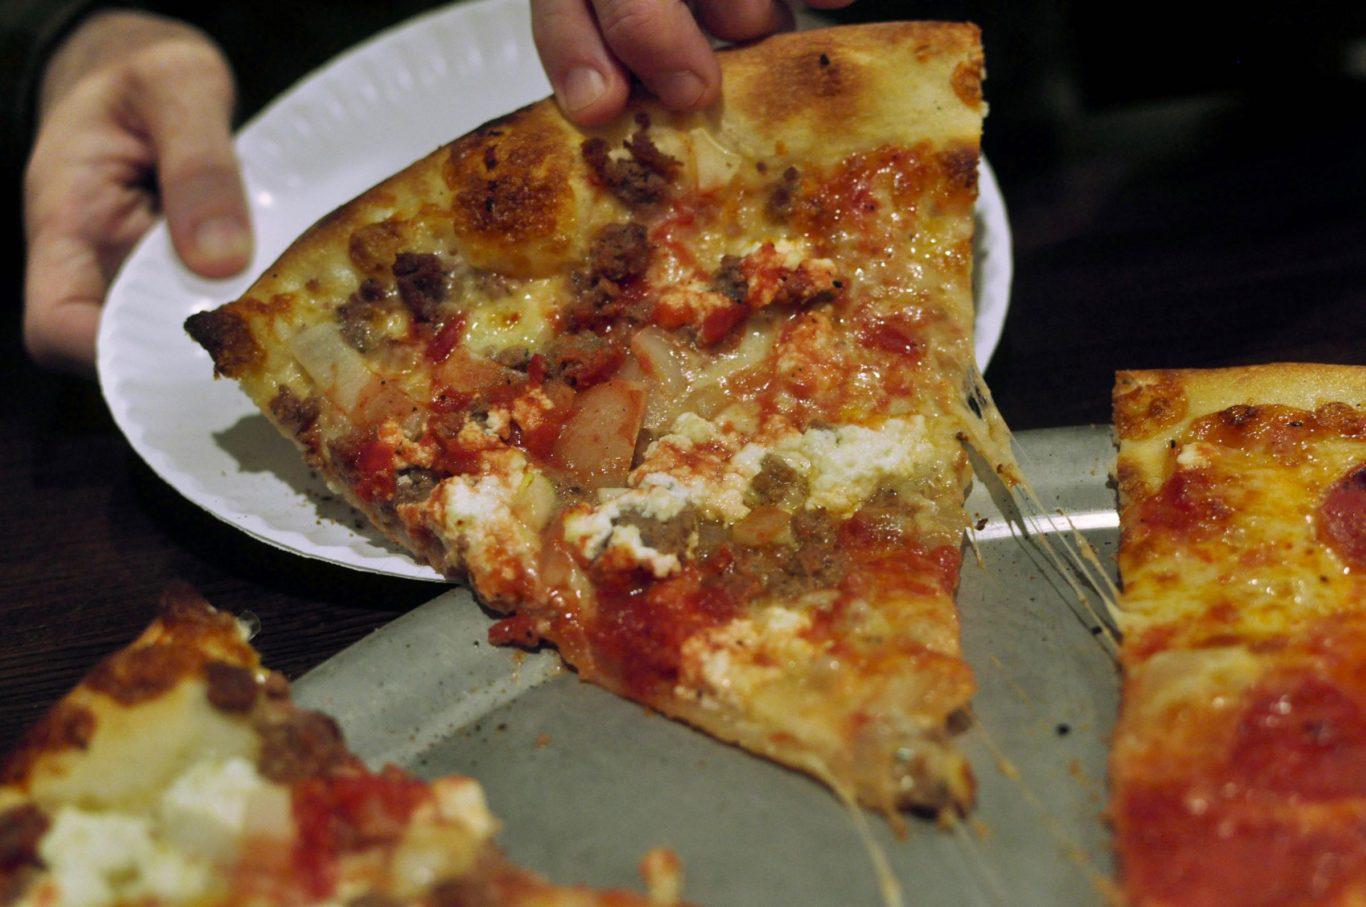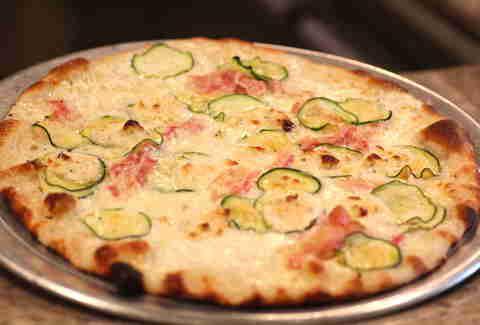The first image is the image on the left, the second image is the image on the right. For the images displayed, is the sentence "A pizza in one image is intact, while a second image shows a slice of pizza and a paper plate." factually correct? Answer yes or no. Yes. The first image is the image on the left, the second image is the image on the right. Analyze the images presented: Is the assertion "The right image shows a whole pizza on a silver tray, and the left image shows one pizza slice on a white paper plate next to a silver tray containing less than a whole pizza." valid? Answer yes or no. Yes. 